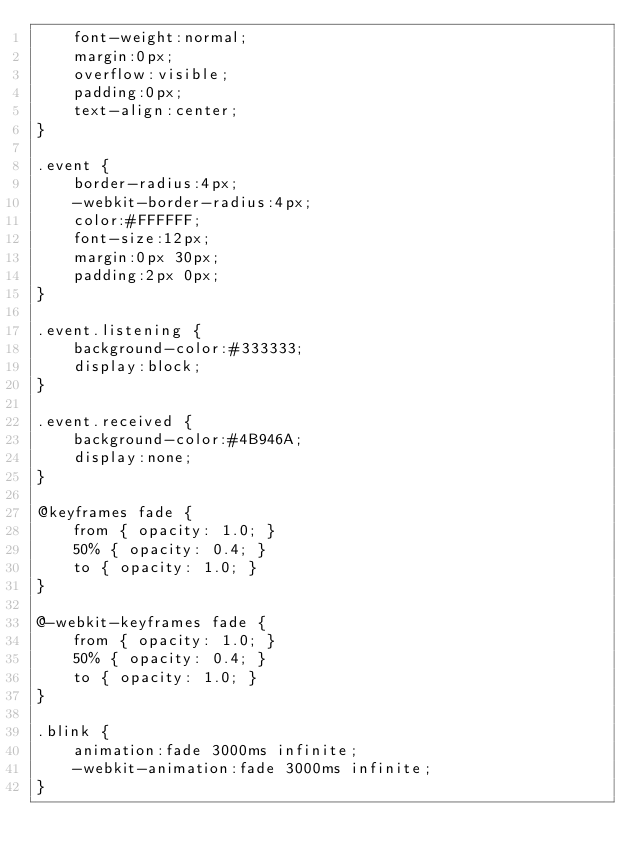Convert code to text. <code><loc_0><loc_0><loc_500><loc_500><_CSS_>    font-weight:normal;
    margin:0px;
    overflow:visible;
    padding:0px;
    text-align:center;
}

.event {
    border-radius:4px;
    -webkit-border-radius:4px;
    color:#FFFFFF;
    font-size:12px;
    margin:0px 30px;
    padding:2px 0px;
}

.event.listening {
    background-color:#333333;
    display:block;
}

.event.received {
    background-color:#4B946A;
    display:none;
}

@keyframes fade {
    from { opacity: 1.0; }
    50% { opacity: 0.4; }
    to { opacity: 1.0; }
}
 
@-webkit-keyframes fade {
    from { opacity: 1.0; }
    50% { opacity: 0.4; }
    to { opacity: 1.0; }
}
 
.blink {
    animation:fade 3000ms infinite;
    -webkit-animation:fade 3000ms infinite;
}
</code> 